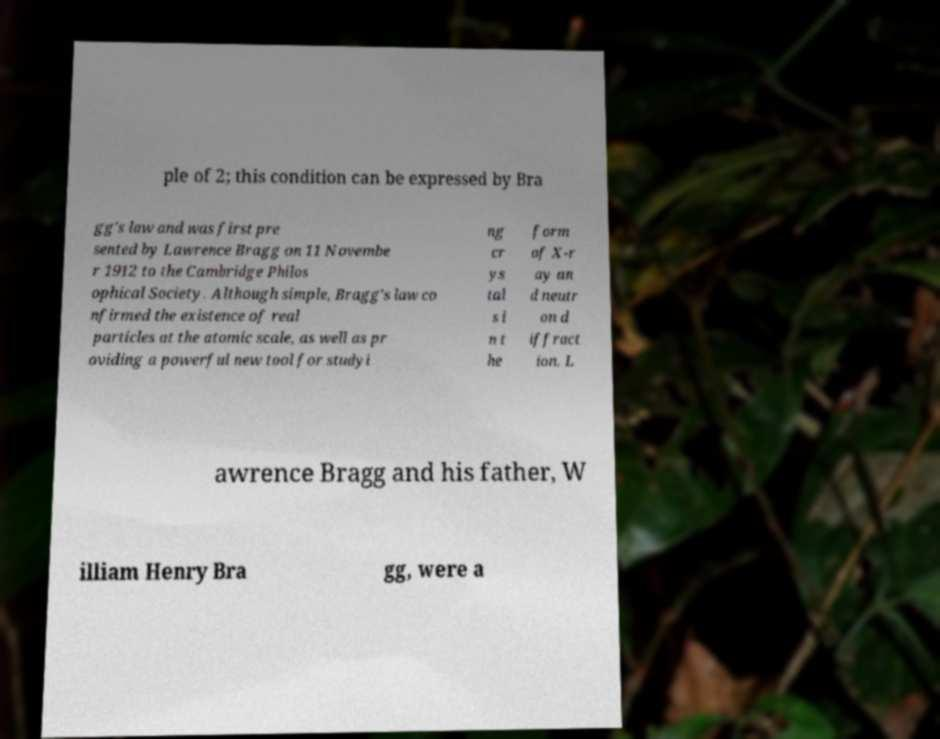There's text embedded in this image that I need extracted. Can you transcribe it verbatim? ple of 2; this condition can be expressed by Bra gg's law and was first pre sented by Lawrence Bragg on 11 Novembe r 1912 to the Cambridge Philos ophical Society. Although simple, Bragg's law co nfirmed the existence of real particles at the atomic scale, as well as pr oviding a powerful new tool for studyi ng cr ys tal s i n t he form of X-r ay an d neutr on d iffract ion. L awrence Bragg and his father, W illiam Henry Bra gg, were a 